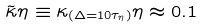Convert formula to latex. <formula><loc_0><loc_0><loc_500><loc_500>\tilde { \kappa } \eta \equiv \kappa _ { ( \Delta = 1 0 \tau _ { \eta } ) } \eta \approx 0 . 1</formula> 